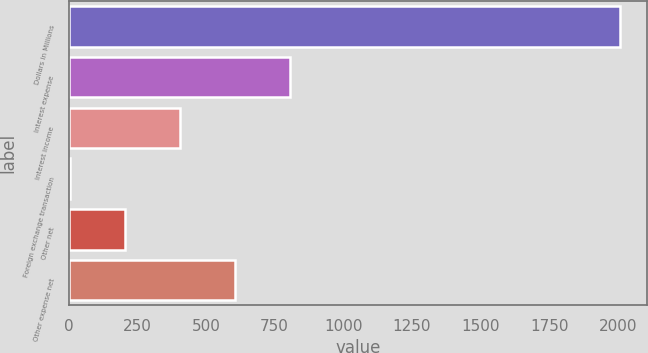Convert chart to OTSL. <chart><loc_0><loc_0><loc_500><loc_500><bar_chart><fcel>Dollars in Millions<fcel>Interest expense<fcel>Interest income<fcel>Foreign exchange transaction<fcel>Other net<fcel>Other expense net<nl><fcel>2006<fcel>806<fcel>406<fcel>6<fcel>206<fcel>606<nl></chart> 